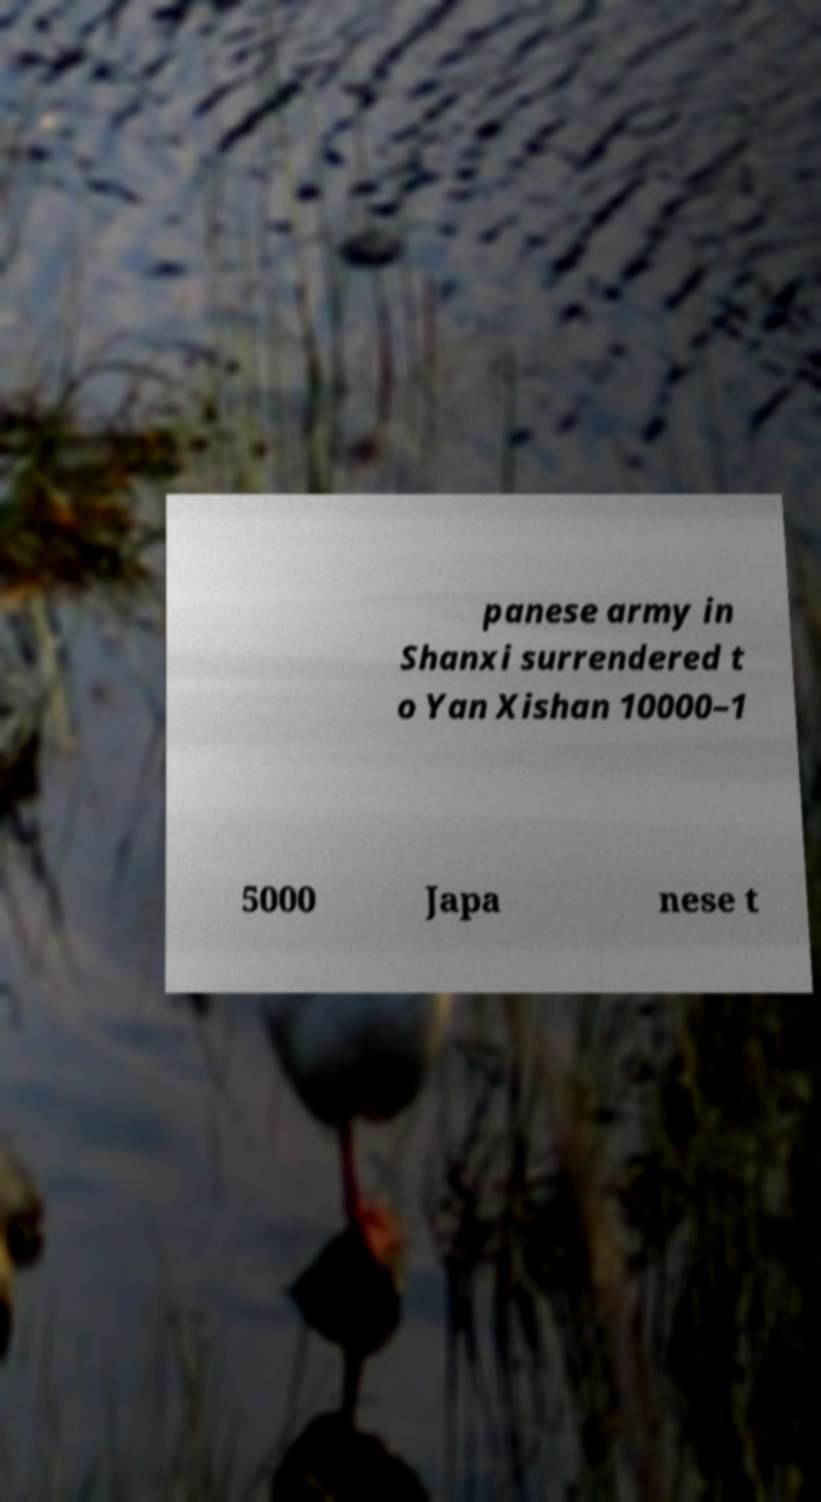For documentation purposes, I need the text within this image transcribed. Could you provide that? panese army in Shanxi surrendered t o Yan Xishan 10000–1 5000 Japa nese t 